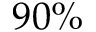Convert formula to latex. <formula><loc_0><loc_0><loc_500><loc_500>9 0 \%</formula> 